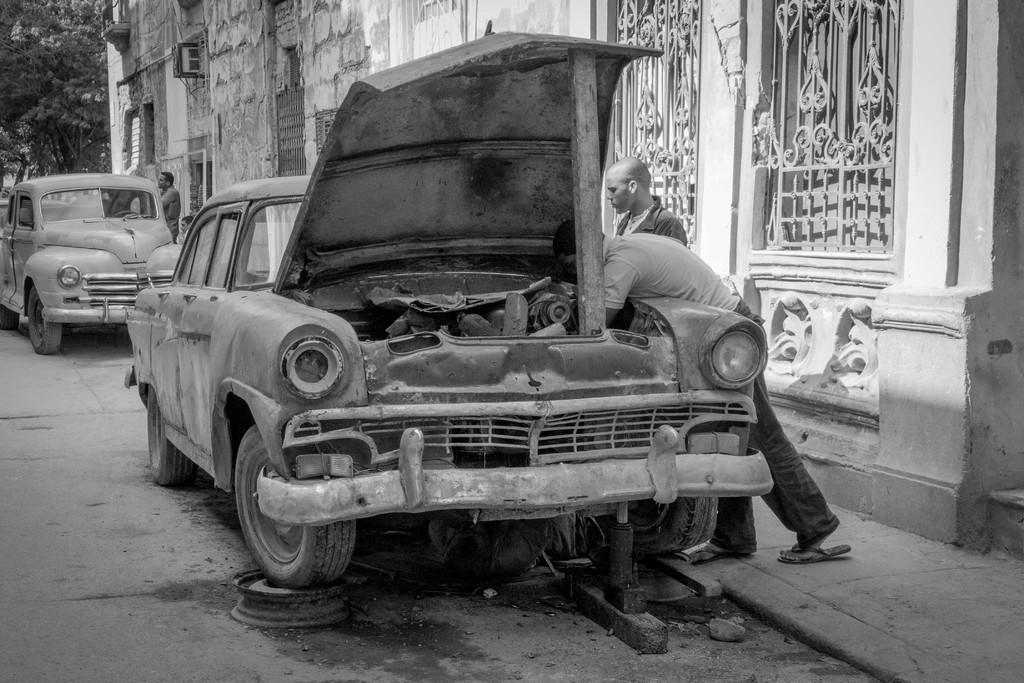What is the color scheme of the image? The image is black and white. How many cars can be seen on the road in the image? There are two cars on the road in the image. What are the people in the image doing? The people are standing on the footpath in the image. What can be seen in the background of the image? There is a building and trees in the background of the image. How many toes can be seen on the people standing on the footpath in the image? There is no visible detail of the people's toes in the image, as it is black and white and the focus is on the cars and the footpath. 